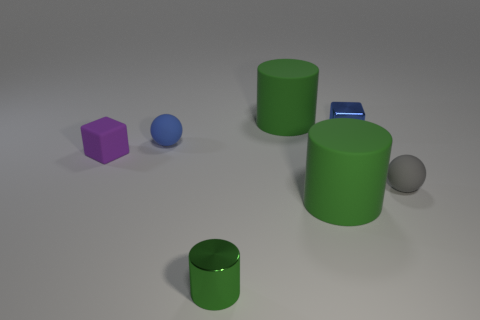How many green metallic cylinders are in front of the small gray rubber object?
Ensure brevity in your answer.  1. There is a large rubber object behind the gray matte object right of the green shiny object; what color is it?
Offer a very short reply. Green. What number of other things are the same material as the small green thing?
Give a very brief answer. 1. Is the number of large matte things behind the small blue cube the same as the number of green objects?
Offer a very short reply. No. The small blue thing to the right of the rubber cylinder that is behind the small matte object right of the small green object is made of what material?
Your answer should be very brief. Metal. There is a ball that is to the right of the small blue block; what is its color?
Offer a terse response. Gray. Is there any other thing that has the same shape as the tiny purple rubber object?
Your response must be concise. Yes. There is a ball on the left side of the small block that is on the right side of the small green object; what is its size?
Offer a very short reply. Small. Is the number of tiny matte objects that are left of the blue metallic block the same as the number of matte blocks that are on the right side of the tiny green object?
Give a very brief answer. No. What color is the other sphere that is the same material as the blue ball?
Make the answer very short. Gray. 